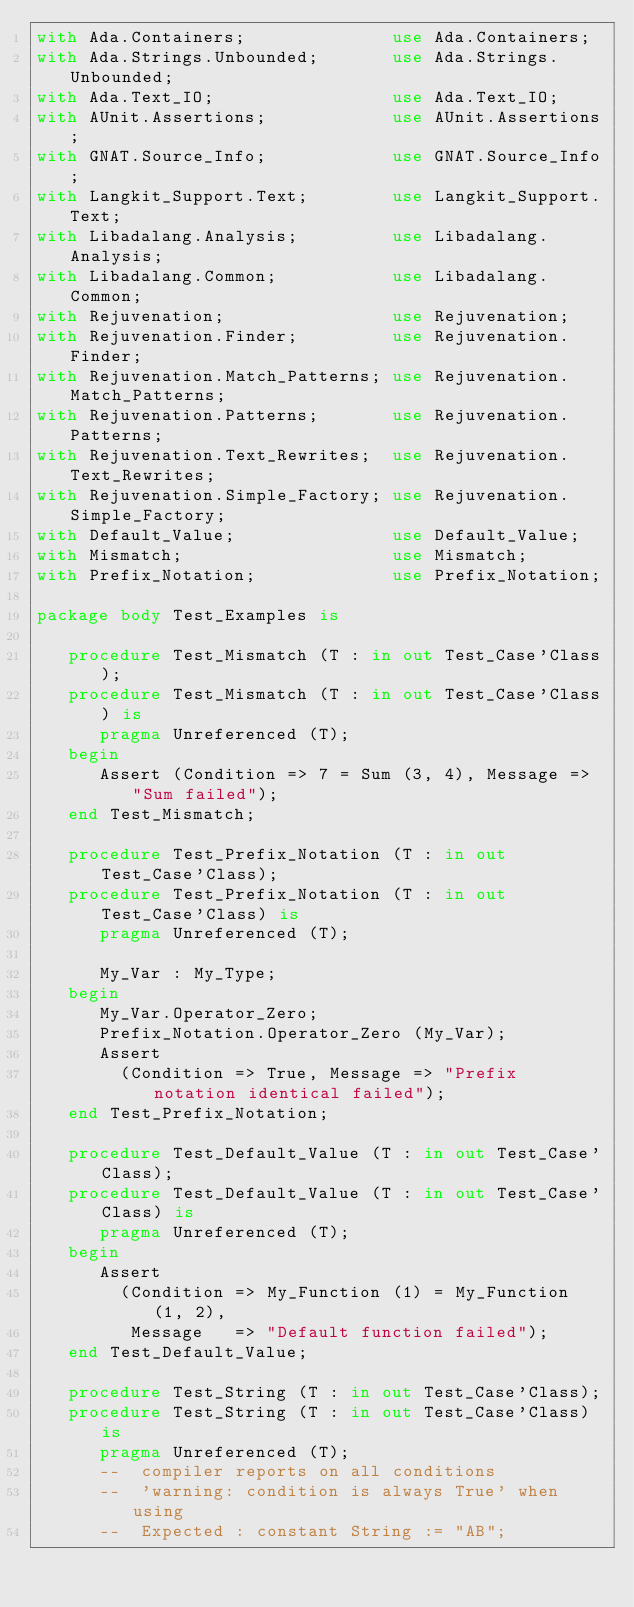<code> <loc_0><loc_0><loc_500><loc_500><_Ada_>with Ada.Containers;              use Ada.Containers;
with Ada.Strings.Unbounded;       use Ada.Strings.Unbounded;
with Ada.Text_IO;                 use Ada.Text_IO;
with AUnit.Assertions;            use AUnit.Assertions;
with GNAT.Source_Info;            use GNAT.Source_Info;
with Langkit_Support.Text;        use Langkit_Support.Text;
with Libadalang.Analysis;         use Libadalang.Analysis;
with Libadalang.Common;           use Libadalang.Common;
with Rejuvenation;                use Rejuvenation;
with Rejuvenation.Finder;         use Rejuvenation.Finder;
with Rejuvenation.Match_Patterns; use Rejuvenation.Match_Patterns;
with Rejuvenation.Patterns;       use Rejuvenation.Patterns;
with Rejuvenation.Text_Rewrites;  use Rejuvenation.Text_Rewrites;
with Rejuvenation.Simple_Factory; use Rejuvenation.Simple_Factory;
with Default_Value;               use Default_Value;
with Mismatch;                    use Mismatch;
with Prefix_Notation;             use Prefix_Notation;

package body Test_Examples is

   procedure Test_Mismatch (T : in out Test_Case'Class);
   procedure Test_Mismatch (T : in out Test_Case'Class) is
      pragma Unreferenced (T);
   begin
      Assert (Condition => 7 = Sum (3, 4), Message => "Sum failed");
   end Test_Mismatch;

   procedure Test_Prefix_Notation (T : in out Test_Case'Class);
   procedure Test_Prefix_Notation (T : in out Test_Case'Class) is
      pragma Unreferenced (T);

      My_Var : My_Type;
   begin
      My_Var.Operator_Zero;
      Prefix_Notation.Operator_Zero (My_Var);
      Assert
        (Condition => True, Message => "Prefix notation identical failed");
   end Test_Prefix_Notation;

   procedure Test_Default_Value (T : in out Test_Case'Class);
   procedure Test_Default_Value (T : in out Test_Case'Class) is
      pragma Unreferenced (T);
   begin
      Assert
        (Condition => My_Function (1) = My_Function (1, 2),
         Message   => "Default function failed");
   end Test_Default_Value;

   procedure Test_String (T : in out Test_Case'Class);
   procedure Test_String (T : in out Test_Case'Class) is
      pragma Unreferenced (T);
      --  compiler reports on all conditions
      --  'warning: condition is always True' when using
      --  Expected : constant String := "AB";</code> 